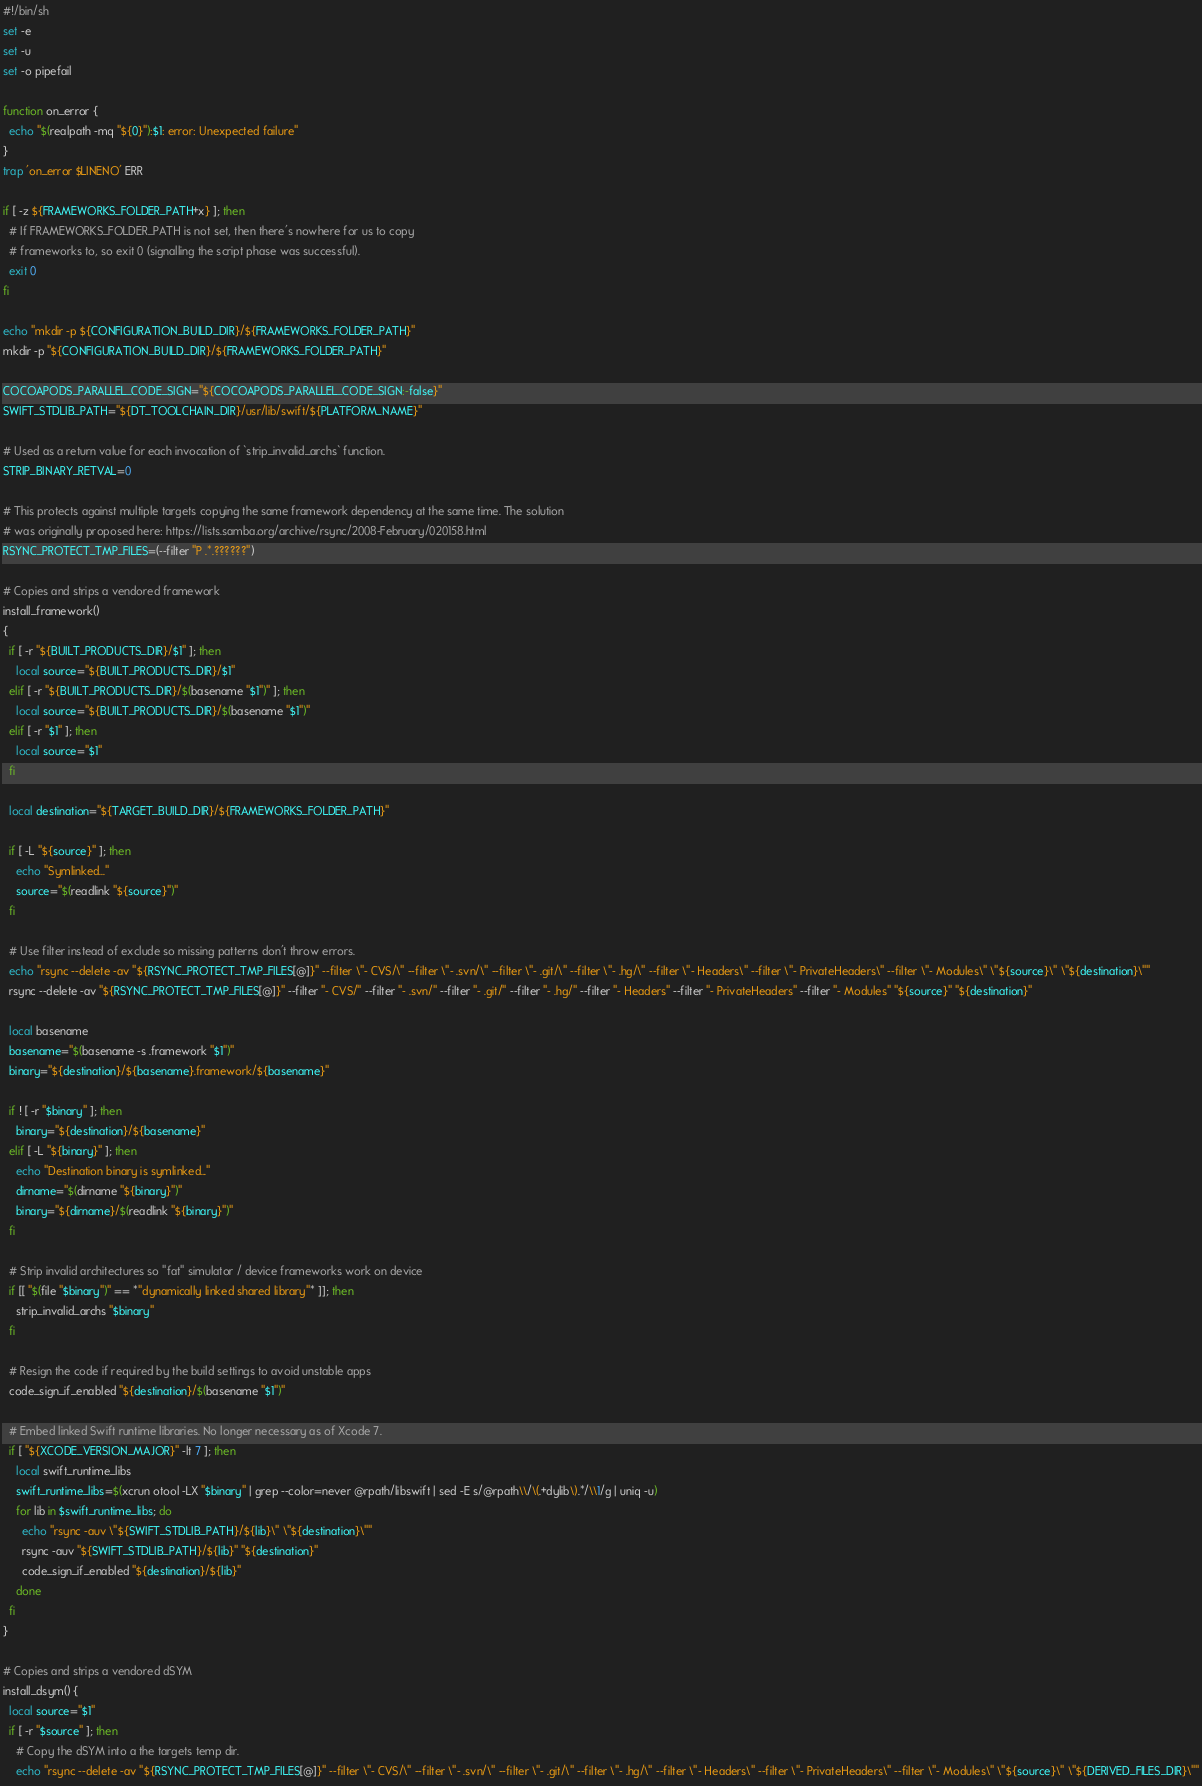<code> <loc_0><loc_0><loc_500><loc_500><_Bash_>#!/bin/sh
set -e
set -u
set -o pipefail

function on_error {
  echo "$(realpath -mq "${0}"):$1: error: Unexpected failure"
}
trap 'on_error $LINENO' ERR

if [ -z ${FRAMEWORKS_FOLDER_PATH+x} ]; then
  # If FRAMEWORKS_FOLDER_PATH is not set, then there's nowhere for us to copy
  # frameworks to, so exit 0 (signalling the script phase was successful).
  exit 0
fi

echo "mkdir -p ${CONFIGURATION_BUILD_DIR}/${FRAMEWORKS_FOLDER_PATH}"
mkdir -p "${CONFIGURATION_BUILD_DIR}/${FRAMEWORKS_FOLDER_PATH}"

COCOAPODS_PARALLEL_CODE_SIGN="${COCOAPODS_PARALLEL_CODE_SIGN:-false}"
SWIFT_STDLIB_PATH="${DT_TOOLCHAIN_DIR}/usr/lib/swift/${PLATFORM_NAME}"

# Used as a return value for each invocation of `strip_invalid_archs` function.
STRIP_BINARY_RETVAL=0

# This protects against multiple targets copying the same framework dependency at the same time. The solution
# was originally proposed here: https://lists.samba.org/archive/rsync/2008-February/020158.html
RSYNC_PROTECT_TMP_FILES=(--filter "P .*.??????")

# Copies and strips a vendored framework
install_framework()
{
  if [ -r "${BUILT_PRODUCTS_DIR}/$1" ]; then
    local source="${BUILT_PRODUCTS_DIR}/$1"
  elif [ -r "${BUILT_PRODUCTS_DIR}/$(basename "$1")" ]; then
    local source="${BUILT_PRODUCTS_DIR}/$(basename "$1")"
  elif [ -r "$1" ]; then
    local source="$1"
  fi

  local destination="${TARGET_BUILD_DIR}/${FRAMEWORKS_FOLDER_PATH}"

  if [ -L "${source}" ]; then
    echo "Symlinked..."
    source="$(readlink "${source}")"
  fi

  # Use filter instead of exclude so missing patterns don't throw errors.
  echo "rsync --delete -av "${RSYNC_PROTECT_TMP_FILES[@]}" --filter \"- CVS/\" --filter \"- .svn/\" --filter \"- .git/\" --filter \"- .hg/\" --filter \"- Headers\" --filter \"- PrivateHeaders\" --filter \"- Modules\" \"${source}\" \"${destination}\""
  rsync --delete -av "${RSYNC_PROTECT_TMP_FILES[@]}" --filter "- CVS/" --filter "- .svn/" --filter "- .git/" --filter "- .hg/" --filter "- Headers" --filter "- PrivateHeaders" --filter "- Modules" "${source}" "${destination}"

  local basename
  basename="$(basename -s .framework "$1")"
  binary="${destination}/${basename}.framework/${basename}"

  if ! [ -r "$binary" ]; then
    binary="${destination}/${basename}"
  elif [ -L "${binary}" ]; then
    echo "Destination binary is symlinked..."
    dirname="$(dirname "${binary}")"
    binary="${dirname}/$(readlink "${binary}")"
  fi

  # Strip invalid architectures so "fat" simulator / device frameworks work on device
  if [[ "$(file "$binary")" == *"dynamically linked shared library"* ]]; then
    strip_invalid_archs "$binary"
  fi

  # Resign the code if required by the build settings to avoid unstable apps
  code_sign_if_enabled "${destination}/$(basename "$1")"

  # Embed linked Swift runtime libraries. No longer necessary as of Xcode 7.
  if [ "${XCODE_VERSION_MAJOR}" -lt 7 ]; then
    local swift_runtime_libs
    swift_runtime_libs=$(xcrun otool -LX "$binary" | grep --color=never @rpath/libswift | sed -E s/@rpath\\/\(.+dylib\).*/\\1/g | uniq -u)
    for lib in $swift_runtime_libs; do
      echo "rsync -auv \"${SWIFT_STDLIB_PATH}/${lib}\" \"${destination}\""
      rsync -auv "${SWIFT_STDLIB_PATH}/${lib}" "${destination}"
      code_sign_if_enabled "${destination}/${lib}"
    done
  fi
}

# Copies and strips a vendored dSYM
install_dsym() {
  local source="$1"
  if [ -r "$source" ]; then
    # Copy the dSYM into a the targets temp dir.
    echo "rsync --delete -av "${RSYNC_PROTECT_TMP_FILES[@]}" --filter \"- CVS/\" --filter \"- .svn/\" --filter \"- .git/\" --filter \"- .hg/\" --filter \"- Headers\" --filter \"- PrivateHeaders\" --filter \"- Modules\" \"${source}\" \"${DERIVED_FILES_DIR}\""</code> 